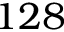<formula> <loc_0><loc_0><loc_500><loc_500>1 2 8</formula> 